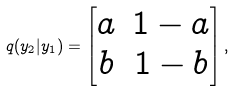Convert formula to latex. <formula><loc_0><loc_0><loc_500><loc_500>q ( y _ { 2 } | y _ { 1 } ) = \begin{bmatrix} a & 1 - a \\ b & 1 - b \end{bmatrix} ,</formula> 